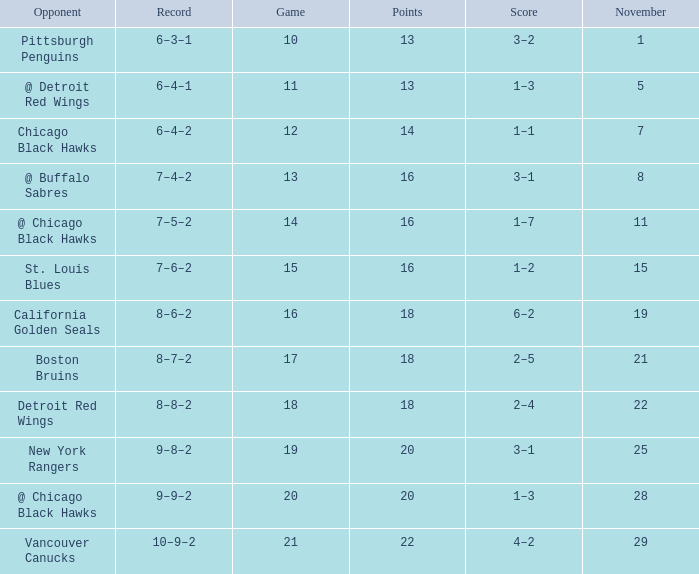Which opponent has points less than 18, and a november greater than 11? St. Louis Blues. 